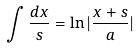Convert formula to latex. <formula><loc_0><loc_0><loc_500><loc_500>\int \frac { d x } { s } = \ln | \frac { x + s } { a } |</formula> 